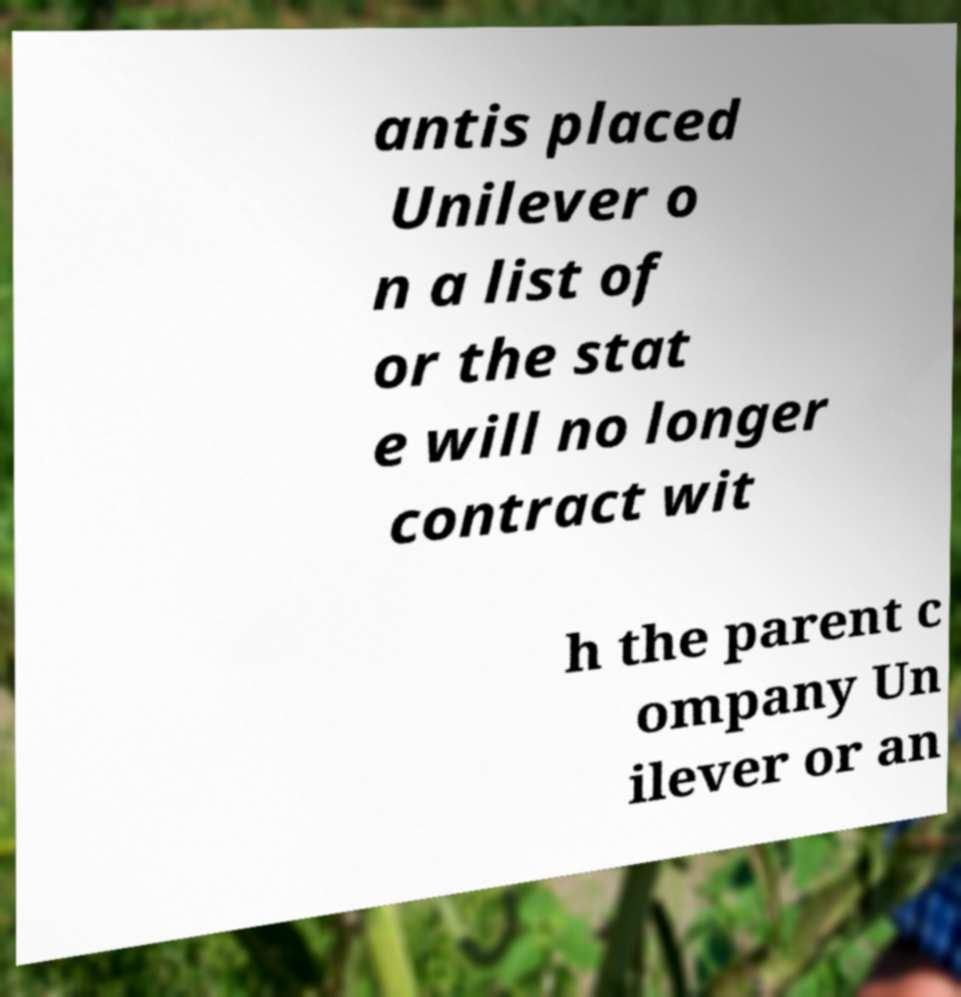Could you assist in decoding the text presented in this image and type it out clearly? antis placed Unilever o n a list of or the stat e will no longer contract wit h the parent c ompany Un ilever or an 